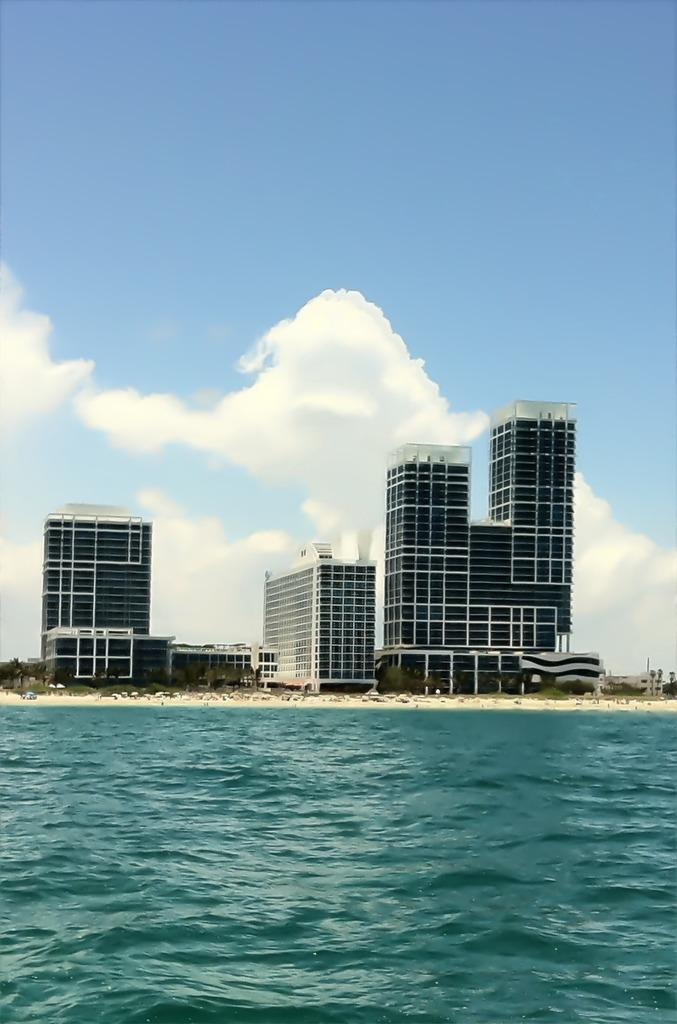What type of structures can be seen in the image? There are buildings in the image. What other natural elements are present in the image? There are trees in the image. Can you describe the people in the image? There might be a group of people on the sand in the image. What is visible at the top of the image? The sky is visible at the top of the image, and there are clouds in the sky. What can be seen at the bottom of the image? There is water and sand visible at the bottom of the image. How many light bulbs are present in the image? There are no light bulbs present in the image. What type of experience can be gained from the edge of the water in the image? The image does not provide information about any experiences that can be gained from the edge of the water. 